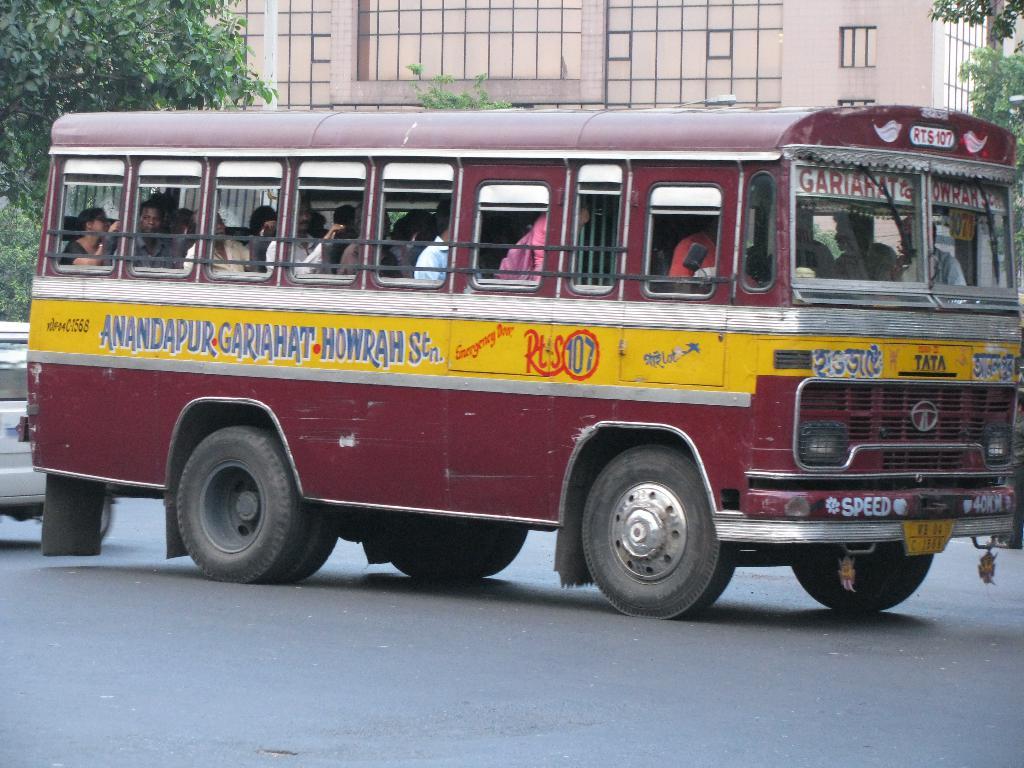What number is circled on the side of the bus?
Provide a succinct answer. 107. 